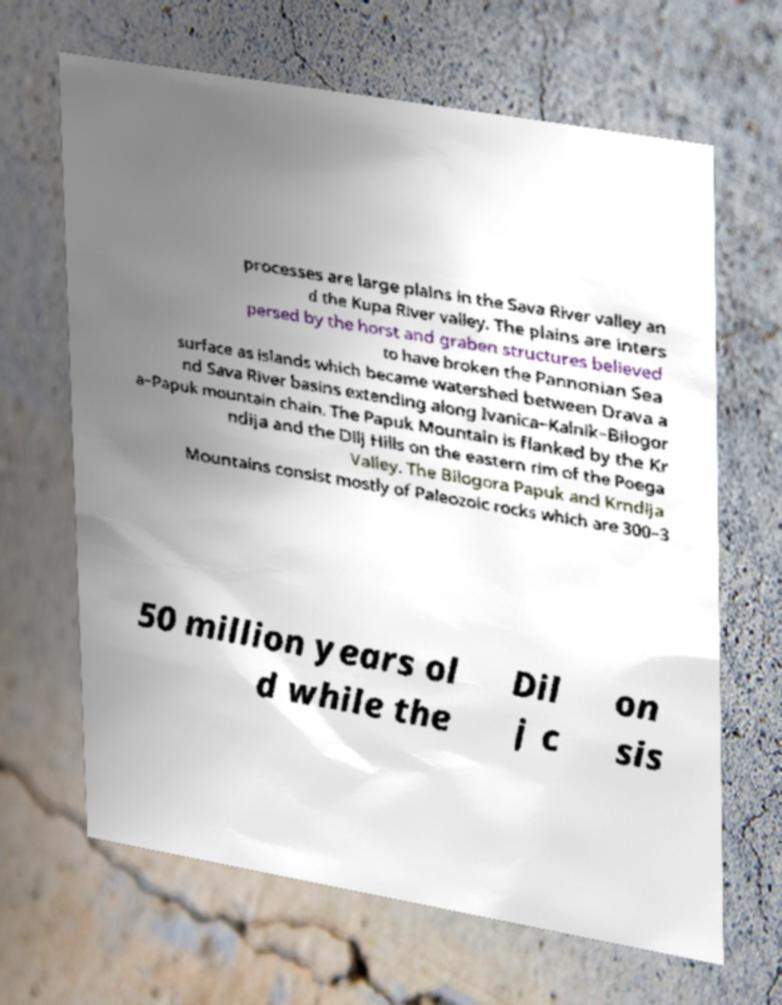Could you extract and type out the text from this image? processes are large plains in the Sava River valley an d the Kupa River valley. The plains are inters persed by the horst and graben structures believed to have broken the Pannonian Sea surface as islands which became watershed between Drava a nd Sava River basins extending along Ivanica–Kalnik–Bilogor a–Papuk mountain chain. The Papuk Mountain is flanked by the Kr ndija and the Dilj Hills on the eastern rim of the Poega Valley. The Bilogora Papuk and Krndija Mountains consist mostly of Paleozoic rocks which are 300–3 50 million years ol d while the Dil j c on sis 